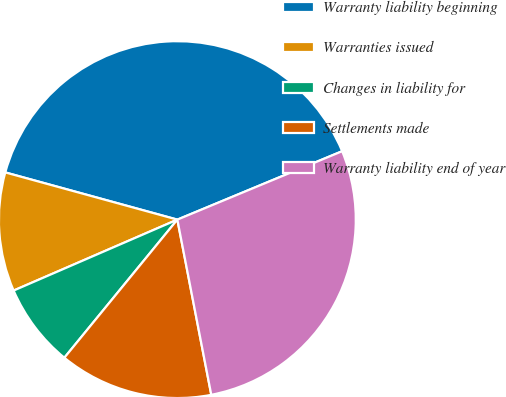<chart> <loc_0><loc_0><loc_500><loc_500><pie_chart><fcel>Warranty liability beginning<fcel>Warranties issued<fcel>Changes in liability for<fcel>Settlements made<fcel>Warranty liability end of year<nl><fcel>39.48%<fcel>10.77%<fcel>7.58%<fcel>13.96%<fcel>28.22%<nl></chart> 